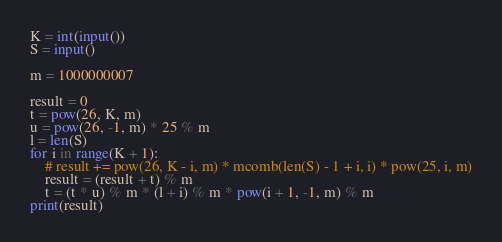Convert code to text. <code><loc_0><loc_0><loc_500><loc_500><_Python_>K = int(input())
S = input()

m = 1000000007

result = 0
t = pow(26, K, m)
u = pow(26, -1, m) * 25 % m
l = len(S)
for i in range(K + 1):
    # result += pow(26, K - i, m) * mcomb(len(S) - 1 + i, i) * pow(25, i, m)
    result = (result + t) % m
    t = (t * u) % m * (l + i) % m * pow(i + 1, -1, m) % m
print(result)
</code> 